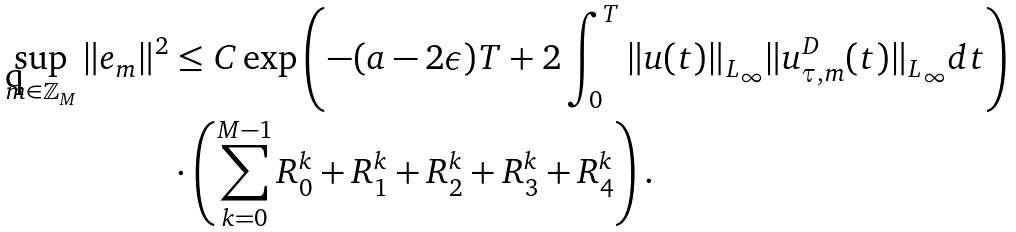<formula> <loc_0><loc_0><loc_500><loc_500>\sup _ { m \in \mathbb { Z } _ { M } } \| e _ { m } \| ^ { 2 } & \leq C \exp \left ( - ( a - 2 \epsilon ) T + 2 \int _ { 0 } ^ { T } \| u ( t ) \| _ { L _ { \infty } } \| u _ { \tau , m } ^ { D } ( t ) \| _ { L _ { \infty } } d t \right ) \\ & \cdot \left ( \sum _ { k = 0 } ^ { M - 1 } R _ { 0 } ^ { k } + R _ { 1 } ^ { k } + R _ { 2 } ^ { k } + R _ { 3 } ^ { k } + R _ { 4 } ^ { k } \right ) .</formula> 